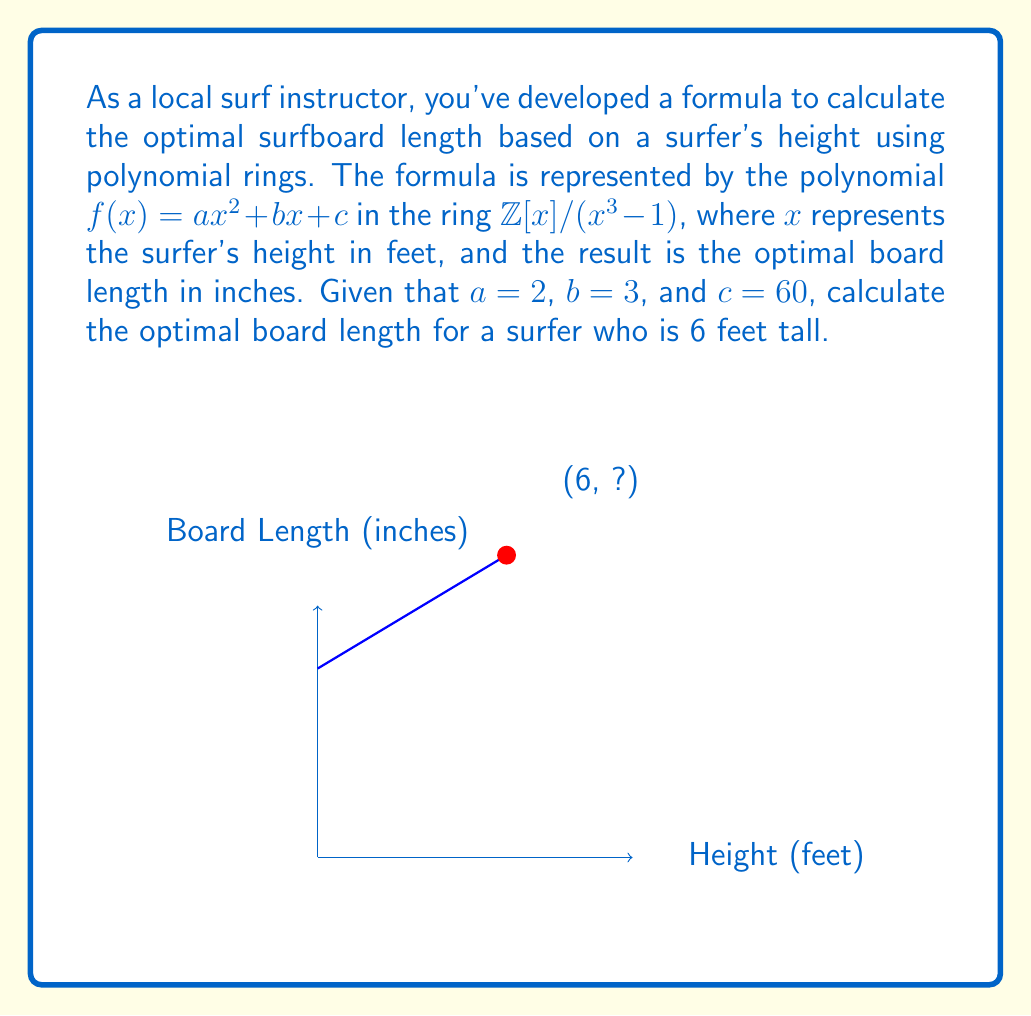What is the answer to this math problem? Let's approach this step-by-step:

1) The given polynomial is $f(x) = 2x^2 + 3x + 60$ in the ring $\mathbb{Z}[x]/(x^3 - 1)$.

2) We need to calculate $f(6)$, but first, we must reduce $6^2$ modulo $x^3 - 1$:
   
   $6^2 = 36 \equiv 0 \pmod{3}$, so $6^2 \equiv 0 \pmod{x^3 - 1}$

3) Now we can calculate $f(6)$:
   
   $f(6) = 2(6^2) + 3(6) + 60$
   
   $\equiv 2(0) + 3(6) + 60 \pmod{x^3 - 1}$
   
   $\equiv 18 + 60 \pmod{x^3 - 1}$
   
   $\equiv 78 \pmod{x^3 - 1}$

4) The result, 78, represents the optimal board length in inches.

5) Note that in the ring $\mathbb{Z}[x]/(x^3 - 1)$, we don't need to reduce 78 further as it's already a constant term.
Answer: 78 inches 